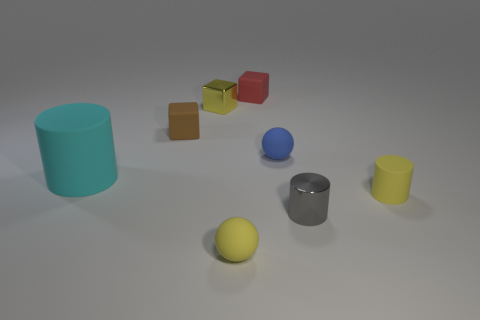Add 1 yellow rubber cylinders. How many objects exist? 9 Subtract all balls. How many objects are left? 6 Add 8 large cyan rubber cylinders. How many large cyan rubber cylinders are left? 9 Add 1 large rubber cylinders. How many large rubber cylinders exist? 2 Subtract 0 blue cylinders. How many objects are left? 8 Subtract all big rubber things. Subtract all large things. How many objects are left? 6 